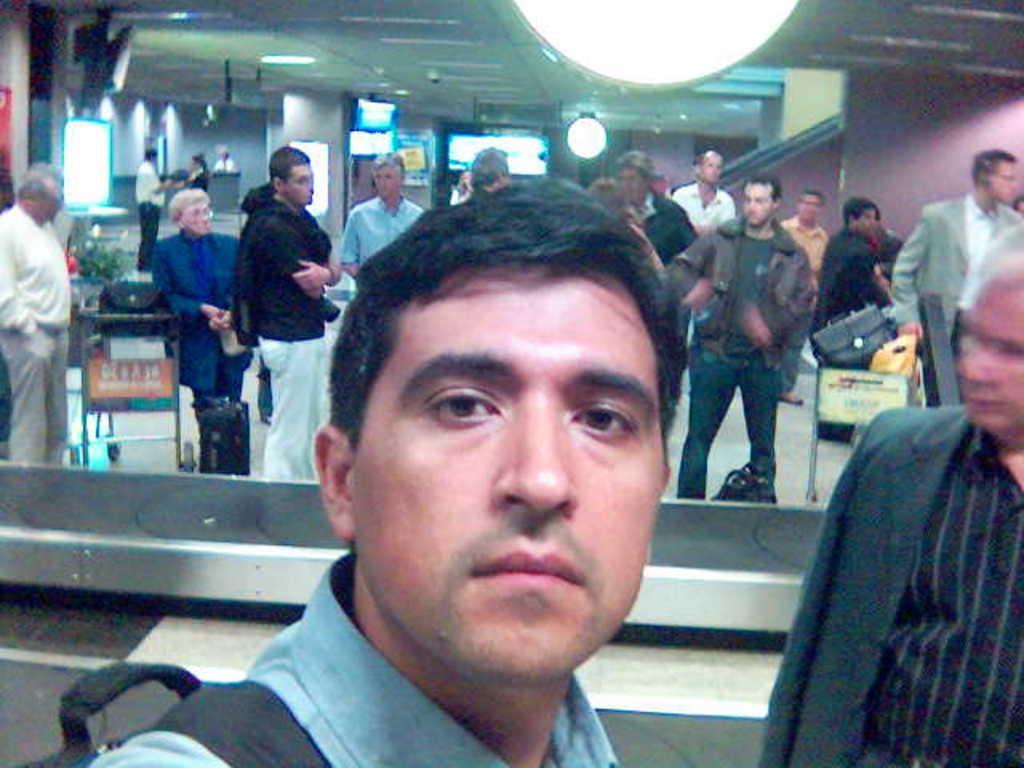In one or two sentences, can you explain what this image depicts? In this image I can see number of people are standing. I can see most of them are wearing jackets and few of them are carrying bags. I can also see few more bags and here I can see few lights on ceiling. I can also see few screens in background. 